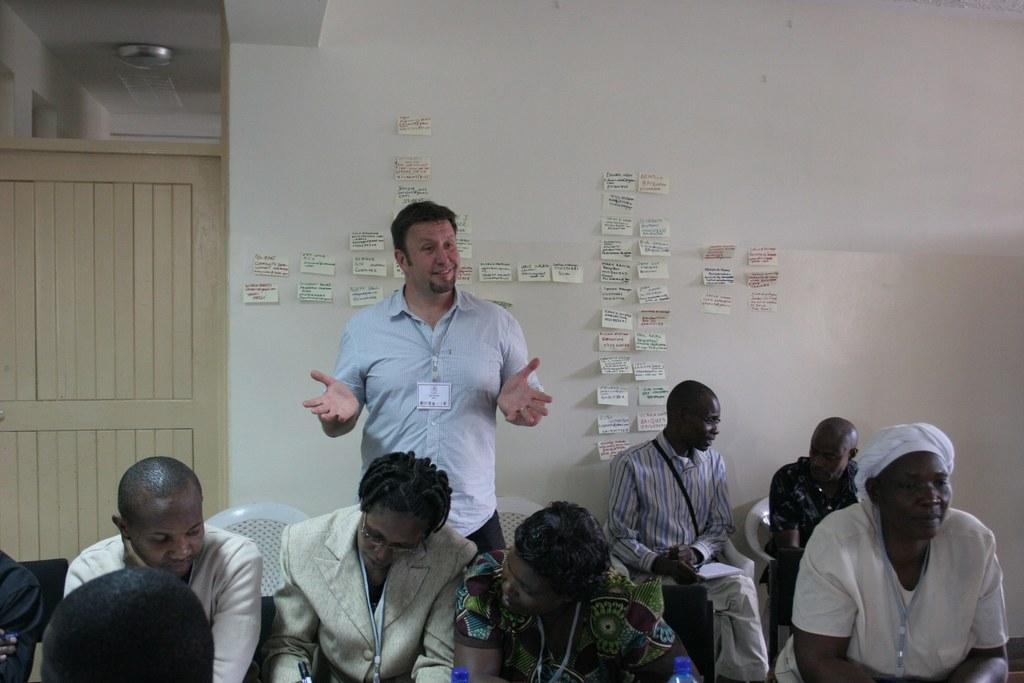Can you describe this image briefly? There are many people sitting on chairs. One person is standing. They are wearing tags. In the back there is a door and a wall. On the wall there are many papers pasted with something written on that. 